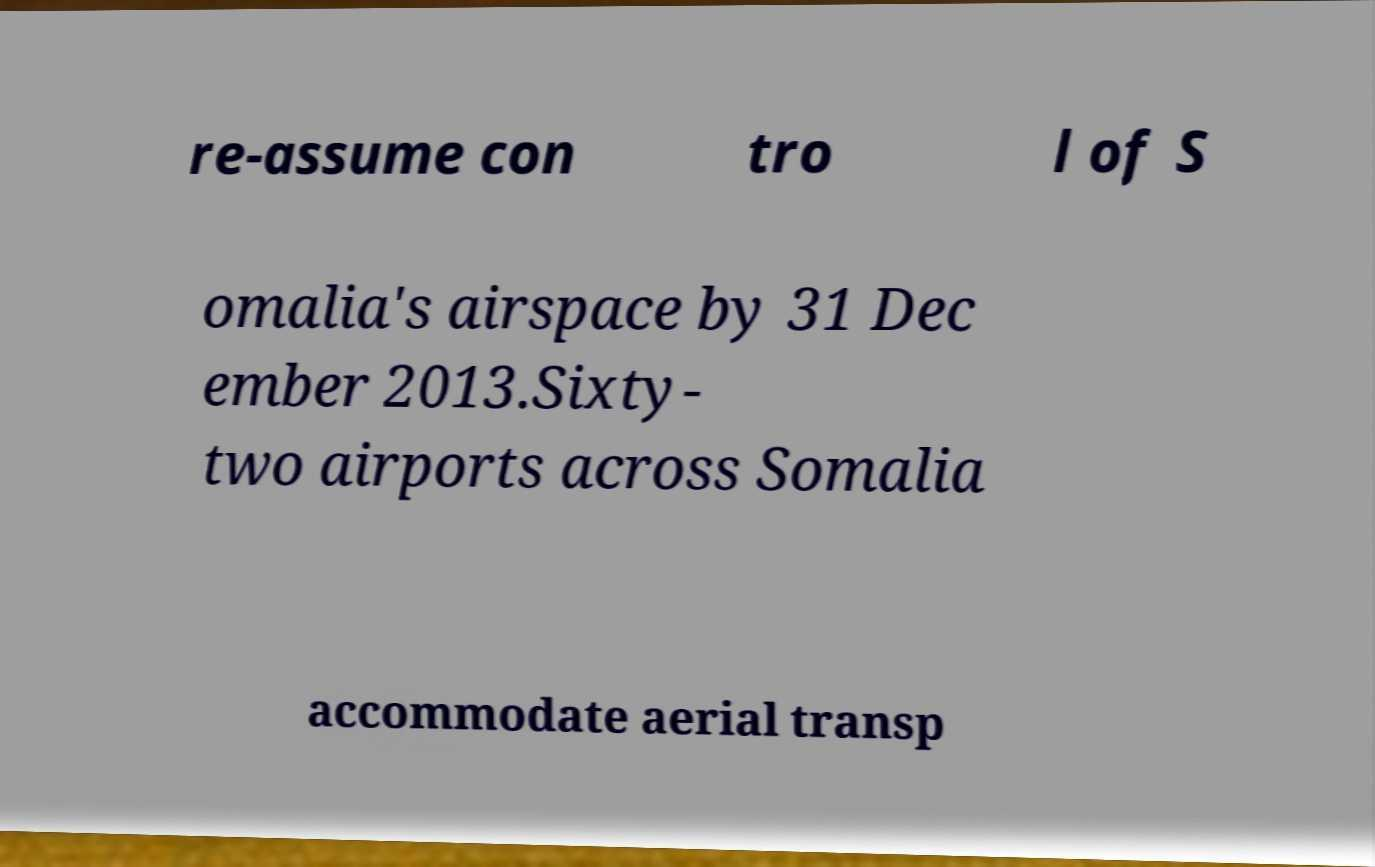Can you read and provide the text displayed in the image?This photo seems to have some interesting text. Can you extract and type it out for me? re-assume con tro l of S omalia's airspace by 31 Dec ember 2013.Sixty- two airports across Somalia accommodate aerial transp 